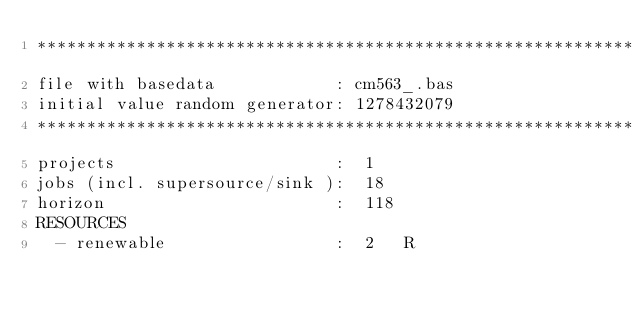Convert code to text. <code><loc_0><loc_0><loc_500><loc_500><_ObjectiveC_>************************************************************************
file with basedata            : cm563_.bas
initial value random generator: 1278432079
************************************************************************
projects                      :  1
jobs (incl. supersource/sink ):  18
horizon                       :  118
RESOURCES
  - renewable                 :  2   R</code> 